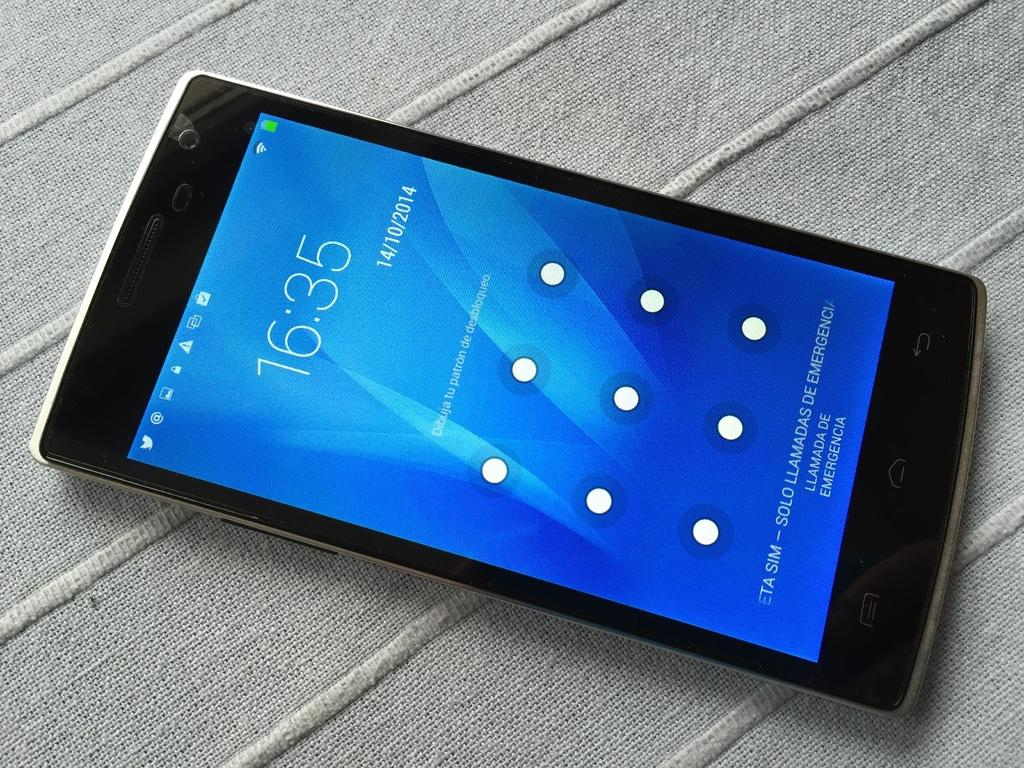<image>
Provide a brief description of the given image. A phone with a blue screen shows the time as 16:35. 